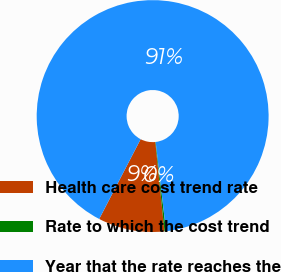Convert chart. <chart><loc_0><loc_0><loc_500><loc_500><pie_chart><fcel>Health care cost trend rate<fcel>Rate to which the cost trend<fcel>Year that the rate reaches the<nl><fcel>9.25%<fcel>0.22%<fcel>90.52%<nl></chart> 